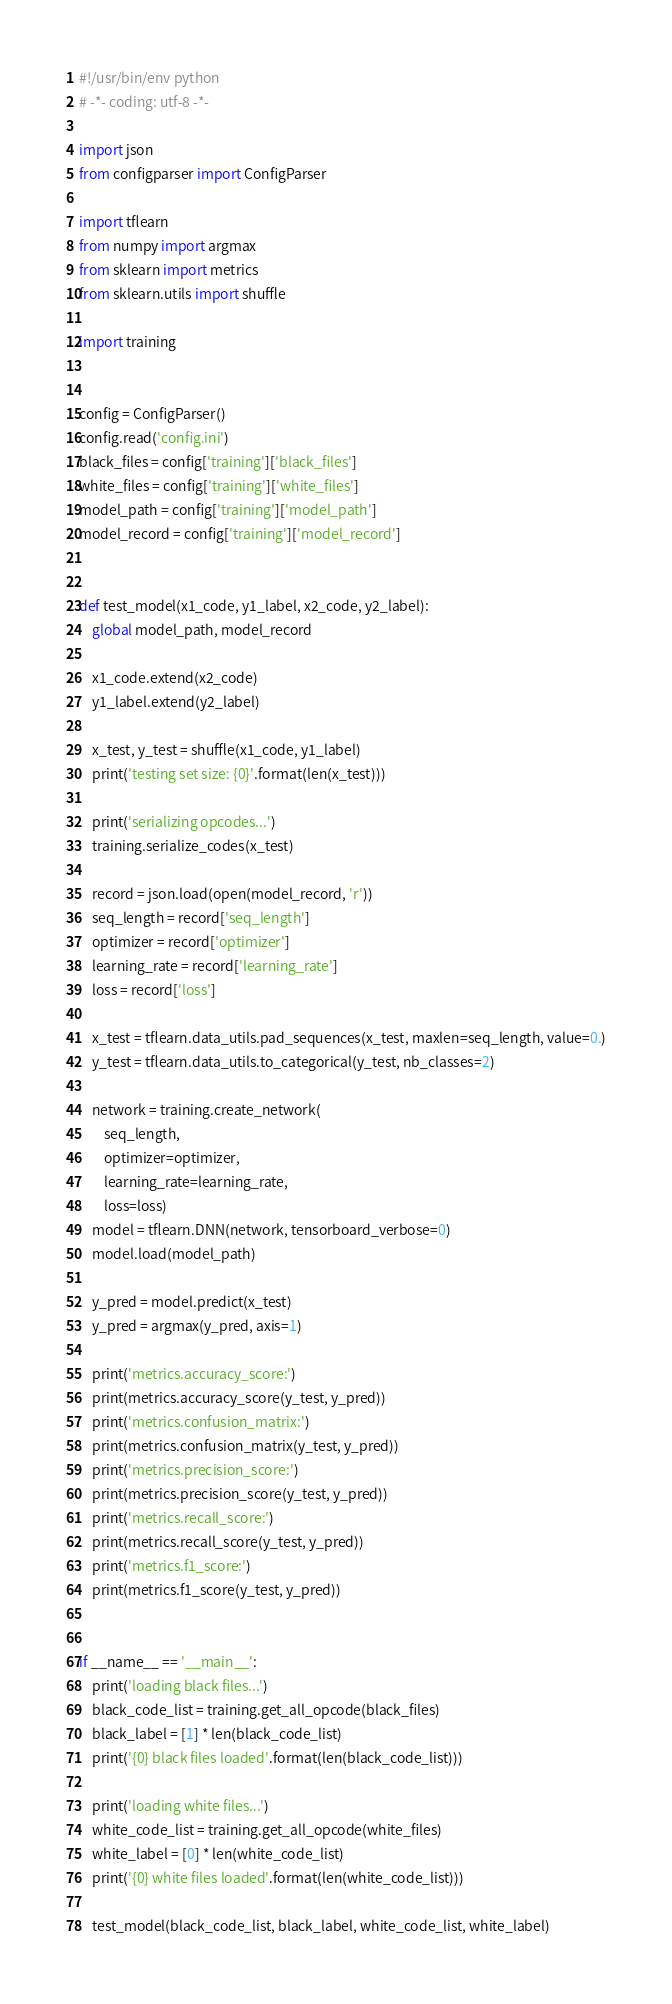<code> <loc_0><loc_0><loc_500><loc_500><_Python_>#!/usr/bin/env python
# -*- coding: utf-8 -*-

import json
from configparser import ConfigParser

import tflearn
from numpy import argmax
from sklearn import metrics
from sklearn.utils import shuffle

import training


config = ConfigParser()
config.read('config.ini')
black_files = config['training']['black_files']
white_files = config['training']['white_files']
model_path = config['training']['model_path']
model_record = config['training']['model_record']


def test_model(x1_code, y1_label, x2_code, y2_label):
    global model_path, model_record

    x1_code.extend(x2_code)
    y1_label.extend(y2_label)

    x_test, y_test = shuffle(x1_code, y1_label)
    print('testing set size: {0}'.format(len(x_test)))

    print('serializing opcodes...')
    training.serialize_codes(x_test)

    record = json.load(open(model_record, 'r'))
    seq_length = record['seq_length']
    optimizer = record['optimizer']
    learning_rate = record['learning_rate']
    loss = record['loss']

    x_test = tflearn.data_utils.pad_sequences(x_test, maxlen=seq_length, value=0.)
    y_test = tflearn.data_utils.to_categorical(y_test, nb_classes=2)

    network = training.create_network(
        seq_length, 
        optimizer=optimizer, 
        learning_rate=learning_rate, 
        loss=loss)
    model = tflearn.DNN(network, tensorboard_verbose=0)
    model.load(model_path)

    y_pred = model.predict(x_test)
    y_pred = argmax(y_pred, axis=1)

    print('metrics.accuracy_score:')
    print(metrics.accuracy_score(y_test, y_pred))
    print('metrics.confusion_matrix:')
    print(metrics.confusion_matrix(y_test, y_pred))
    print('metrics.precision_score:')
    print(metrics.precision_score(y_test, y_pred))
    print('metrics.recall_score:')
    print(metrics.recall_score(y_test, y_pred))
    print('metrics.f1_score:')
    print(metrics.f1_score(y_test, y_pred))


if __name__ == '__main__':
    print('loading black files...')
    black_code_list = training.get_all_opcode(black_files)
    black_label = [1] * len(black_code_list)
    print('{0} black files loaded'.format(len(black_code_list)))

    print('loading white files...')
    white_code_list = training.get_all_opcode(white_files)
    white_label = [0] * len(white_code_list)
    print('{0} white files loaded'.format(len(white_code_list)))

    test_model(black_code_list, black_label, white_code_list, white_label)
</code> 